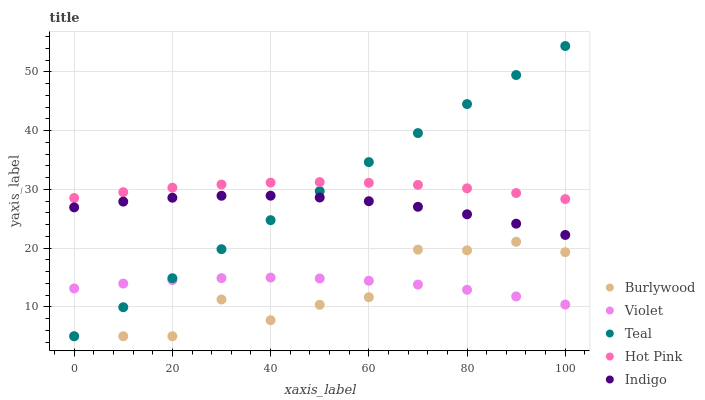Does Burlywood have the minimum area under the curve?
Answer yes or no. Yes. Does Hot Pink have the maximum area under the curve?
Answer yes or no. Yes. Does Indigo have the minimum area under the curve?
Answer yes or no. No. Does Indigo have the maximum area under the curve?
Answer yes or no. No. Is Teal the smoothest?
Answer yes or no. Yes. Is Burlywood the roughest?
Answer yes or no. Yes. Is Hot Pink the smoothest?
Answer yes or no. No. Is Hot Pink the roughest?
Answer yes or no. No. Does Burlywood have the lowest value?
Answer yes or no. Yes. Does Indigo have the lowest value?
Answer yes or no. No. Does Teal have the highest value?
Answer yes or no. Yes. Does Hot Pink have the highest value?
Answer yes or no. No. Is Burlywood less than Indigo?
Answer yes or no. Yes. Is Hot Pink greater than Burlywood?
Answer yes or no. Yes. Does Teal intersect Violet?
Answer yes or no. Yes. Is Teal less than Violet?
Answer yes or no. No. Is Teal greater than Violet?
Answer yes or no. No. Does Burlywood intersect Indigo?
Answer yes or no. No. 